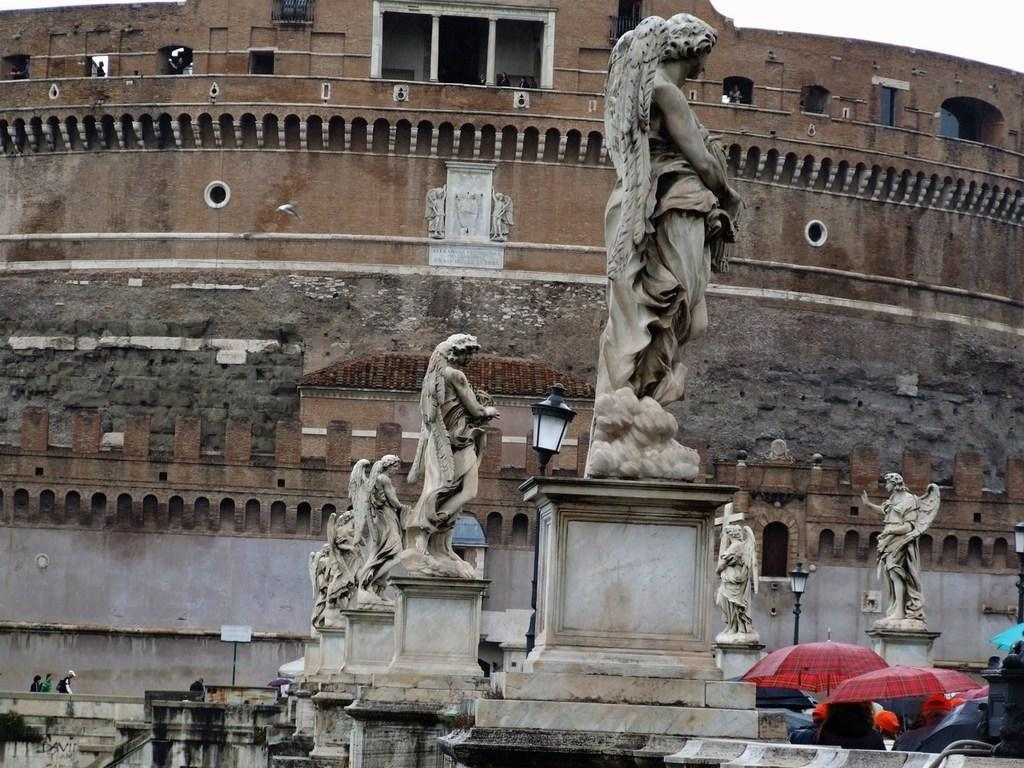What can be seen in the image besides the building? There are different sculptures in the image. What might be the purpose of the building behind the sculptures? The building could be a museum or gallery, as it is located behind the sculptures. What are the people on the right side of the image doing? The people on the right side of the image are holding umbrellas. What is the price of the sculpture on the left side of the image? There is no price information provided for the sculptures in the image. 